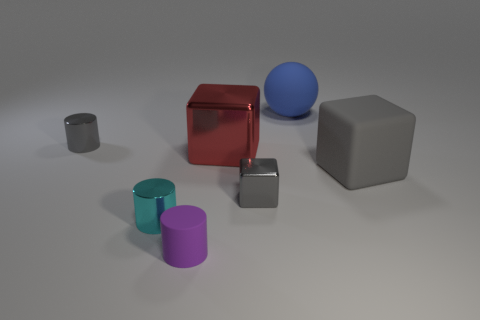Subtract all large cubes. How many cubes are left? 1 Subtract all yellow cylinders. How many gray cubes are left? 2 Add 2 large red metal blocks. How many objects exist? 9 Subtract all blocks. How many objects are left? 4 Subtract all yellow blocks. Subtract all brown spheres. How many blocks are left? 3 Add 7 big red things. How many big red things are left? 8 Add 1 matte spheres. How many matte spheres exist? 2 Subtract 1 red cubes. How many objects are left? 6 Subtract all shiny blocks. Subtract all large metal objects. How many objects are left? 4 